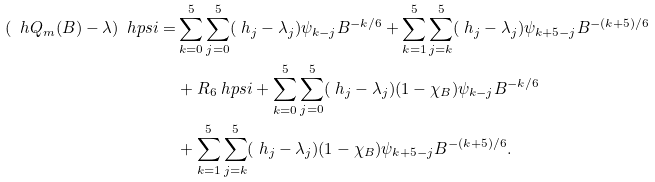<formula> <loc_0><loc_0><loc_500><loc_500>( \ h Q _ { m } ( B ) - \lambda ) \ h p s i = & \sum _ { k = 0 } ^ { 5 } \sum _ { j = 0 } ^ { 5 } ( \ h _ { j } - \lambda _ { j } ) \psi _ { k - j } B ^ { - k / 6 } + \sum _ { k = 1 } ^ { 5 } \sum _ { j = k } ^ { 5 } ( \ h _ { j } - \lambda _ { j } ) \psi _ { k + 5 - j } B ^ { - ( k + 5 ) / 6 } \\ & + R _ { 6 } \ h p s i + \sum _ { k = 0 } ^ { 5 } \sum _ { j = 0 } ^ { 5 } ( \ h _ { j } - \lambda _ { j } ) ( 1 - \chi _ { B } ) \psi _ { k - j } B ^ { - k / 6 } \\ & + \sum _ { k = 1 } ^ { 5 } \sum _ { j = k } ^ { 5 } ( \ h _ { j } - \lambda _ { j } ) ( 1 - \chi _ { B } ) \psi _ { k + 5 - j } B ^ { - ( k + 5 ) / 6 } .</formula> 